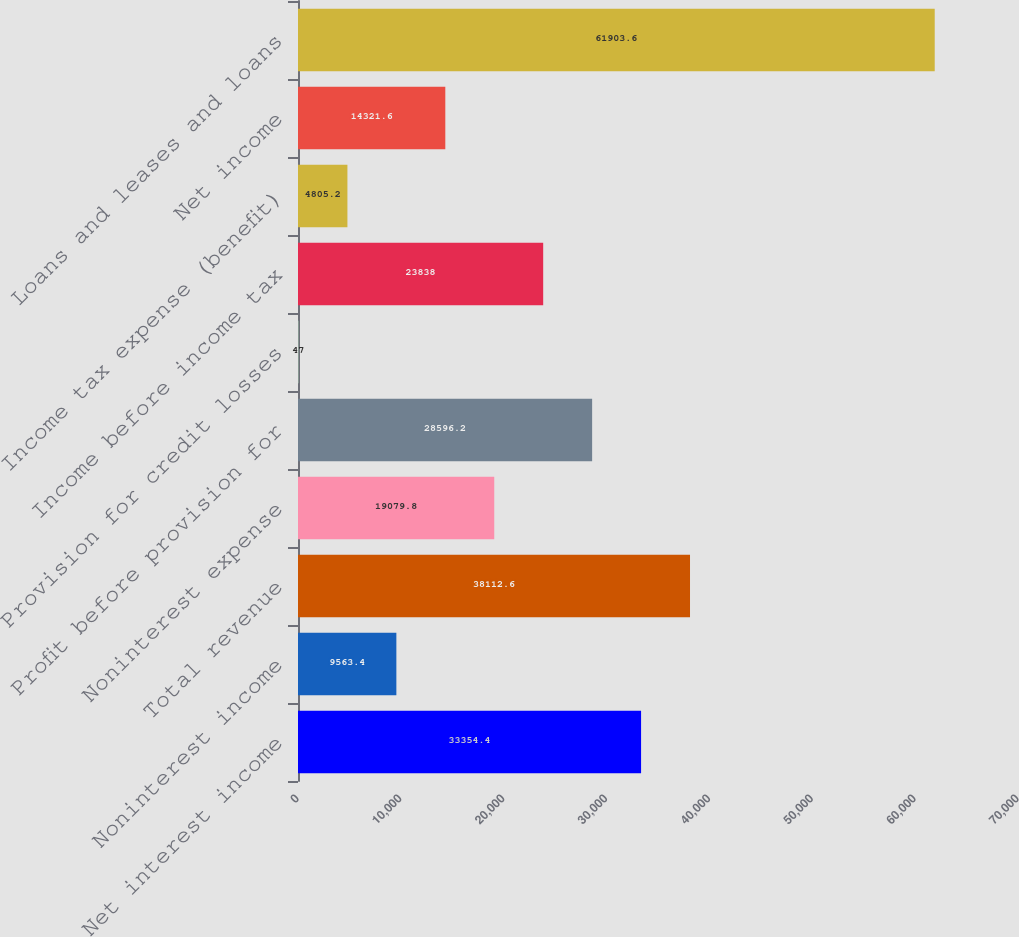Convert chart to OTSL. <chart><loc_0><loc_0><loc_500><loc_500><bar_chart><fcel>Net interest income<fcel>Noninterest income<fcel>Total revenue<fcel>Noninterest expense<fcel>Profit before provision for<fcel>Provision for credit losses<fcel>Income before income tax<fcel>Income tax expense (benefit)<fcel>Net income<fcel>Loans and leases and loans<nl><fcel>33354.4<fcel>9563.4<fcel>38112.6<fcel>19079.8<fcel>28596.2<fcel>47<fcel>23838<fcel>4805.2<fcel>14321.6<fcel>61903.6<nl></chart> 